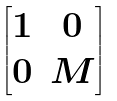Convert formula to latex. <formula><loc_0><loc_0><loc_500><loc_500>\begin{bmatrix} 1 & 0 \\ 0 & M \end{bmatrix}</formula> 